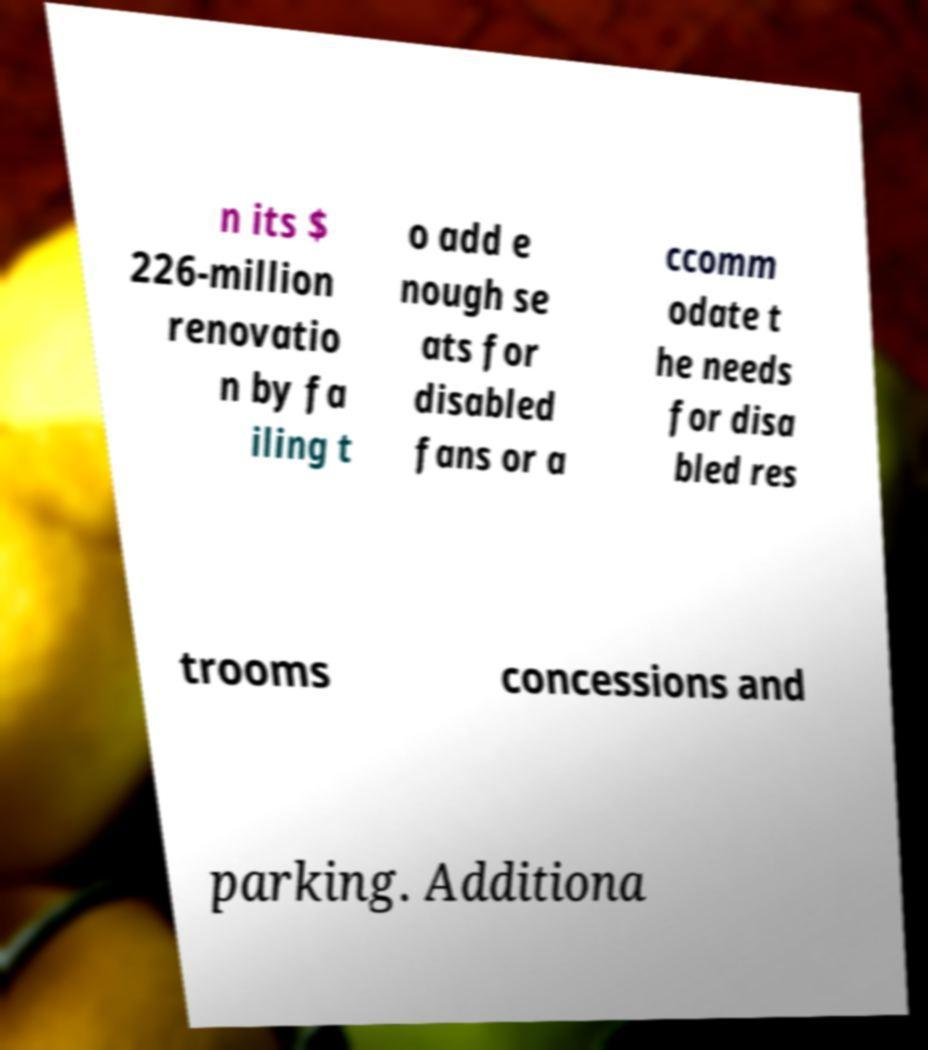There's text embedded in this image that I need extracted. Can you transcribe it verbatim? n its $ 226-million renovatio n by fa iling t o add e nough se ats for disabled fans or a ccomm odate t he needs for disa bled res trooms concessions and parking. Additiona 